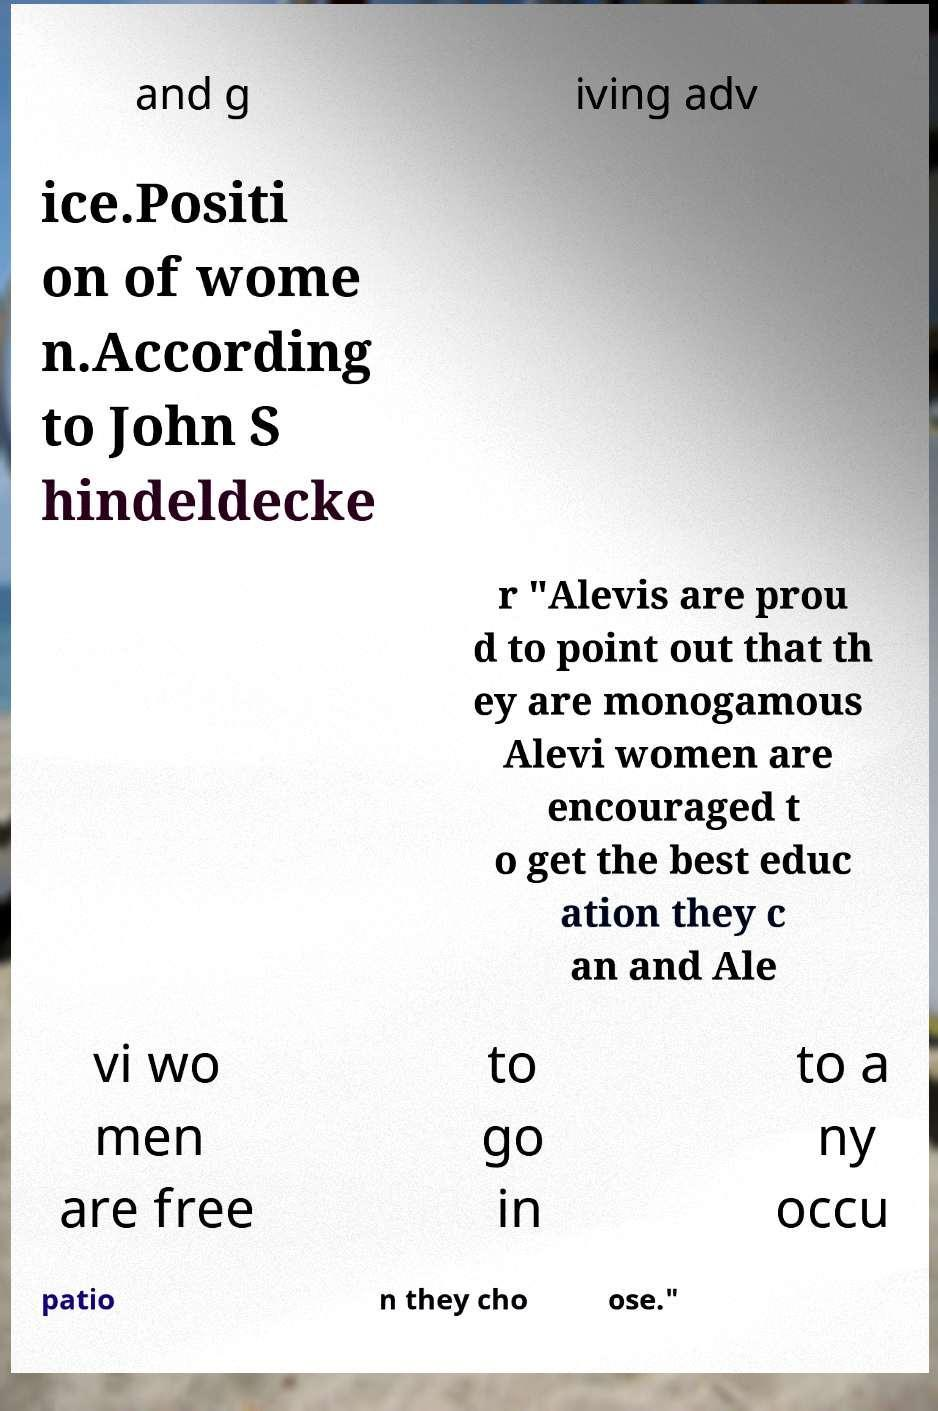Please read and relay the text visible in this image. What does it say? and g iving adv ice.Positi on of wome n.According to John S hindeldecke r "Alevis are prou d to point out that th ey are monogamous Alevi women are encouraged t o get the best educ ation they c an and Ale vi wo men are free to go in to a ny occu patio n they cho ose." 